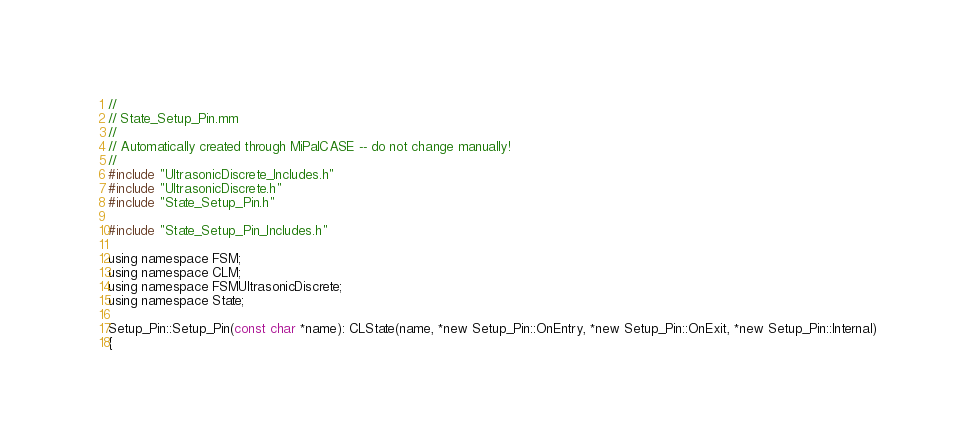Convert code to text. <code><loc_0><loc_0><loc_500><loc_500><_ObjectiveC_>//
// State_Setup_Pin.mm
//
// Automatically created through MiPalCASE -- do not change manually!
//
#include "UltrasonicDiscrete_Includes.h"
#include "UltrasonicDiscrete.h"
#include "State_Setup_Pin.h"

#include "State_Setup_Pin_Includes.h"

using namespace FSM;
using namespace CLM;
using namespace FSMUltrasonicDiscrete;
using namespace State;

Setup_Pin::Setup_Pin(const char *name): CLState(name, *new Setup_Pin::OnEntry, *new Setup_Pin::OnExit, *new Setup_Pin::Internal)
{</code> 